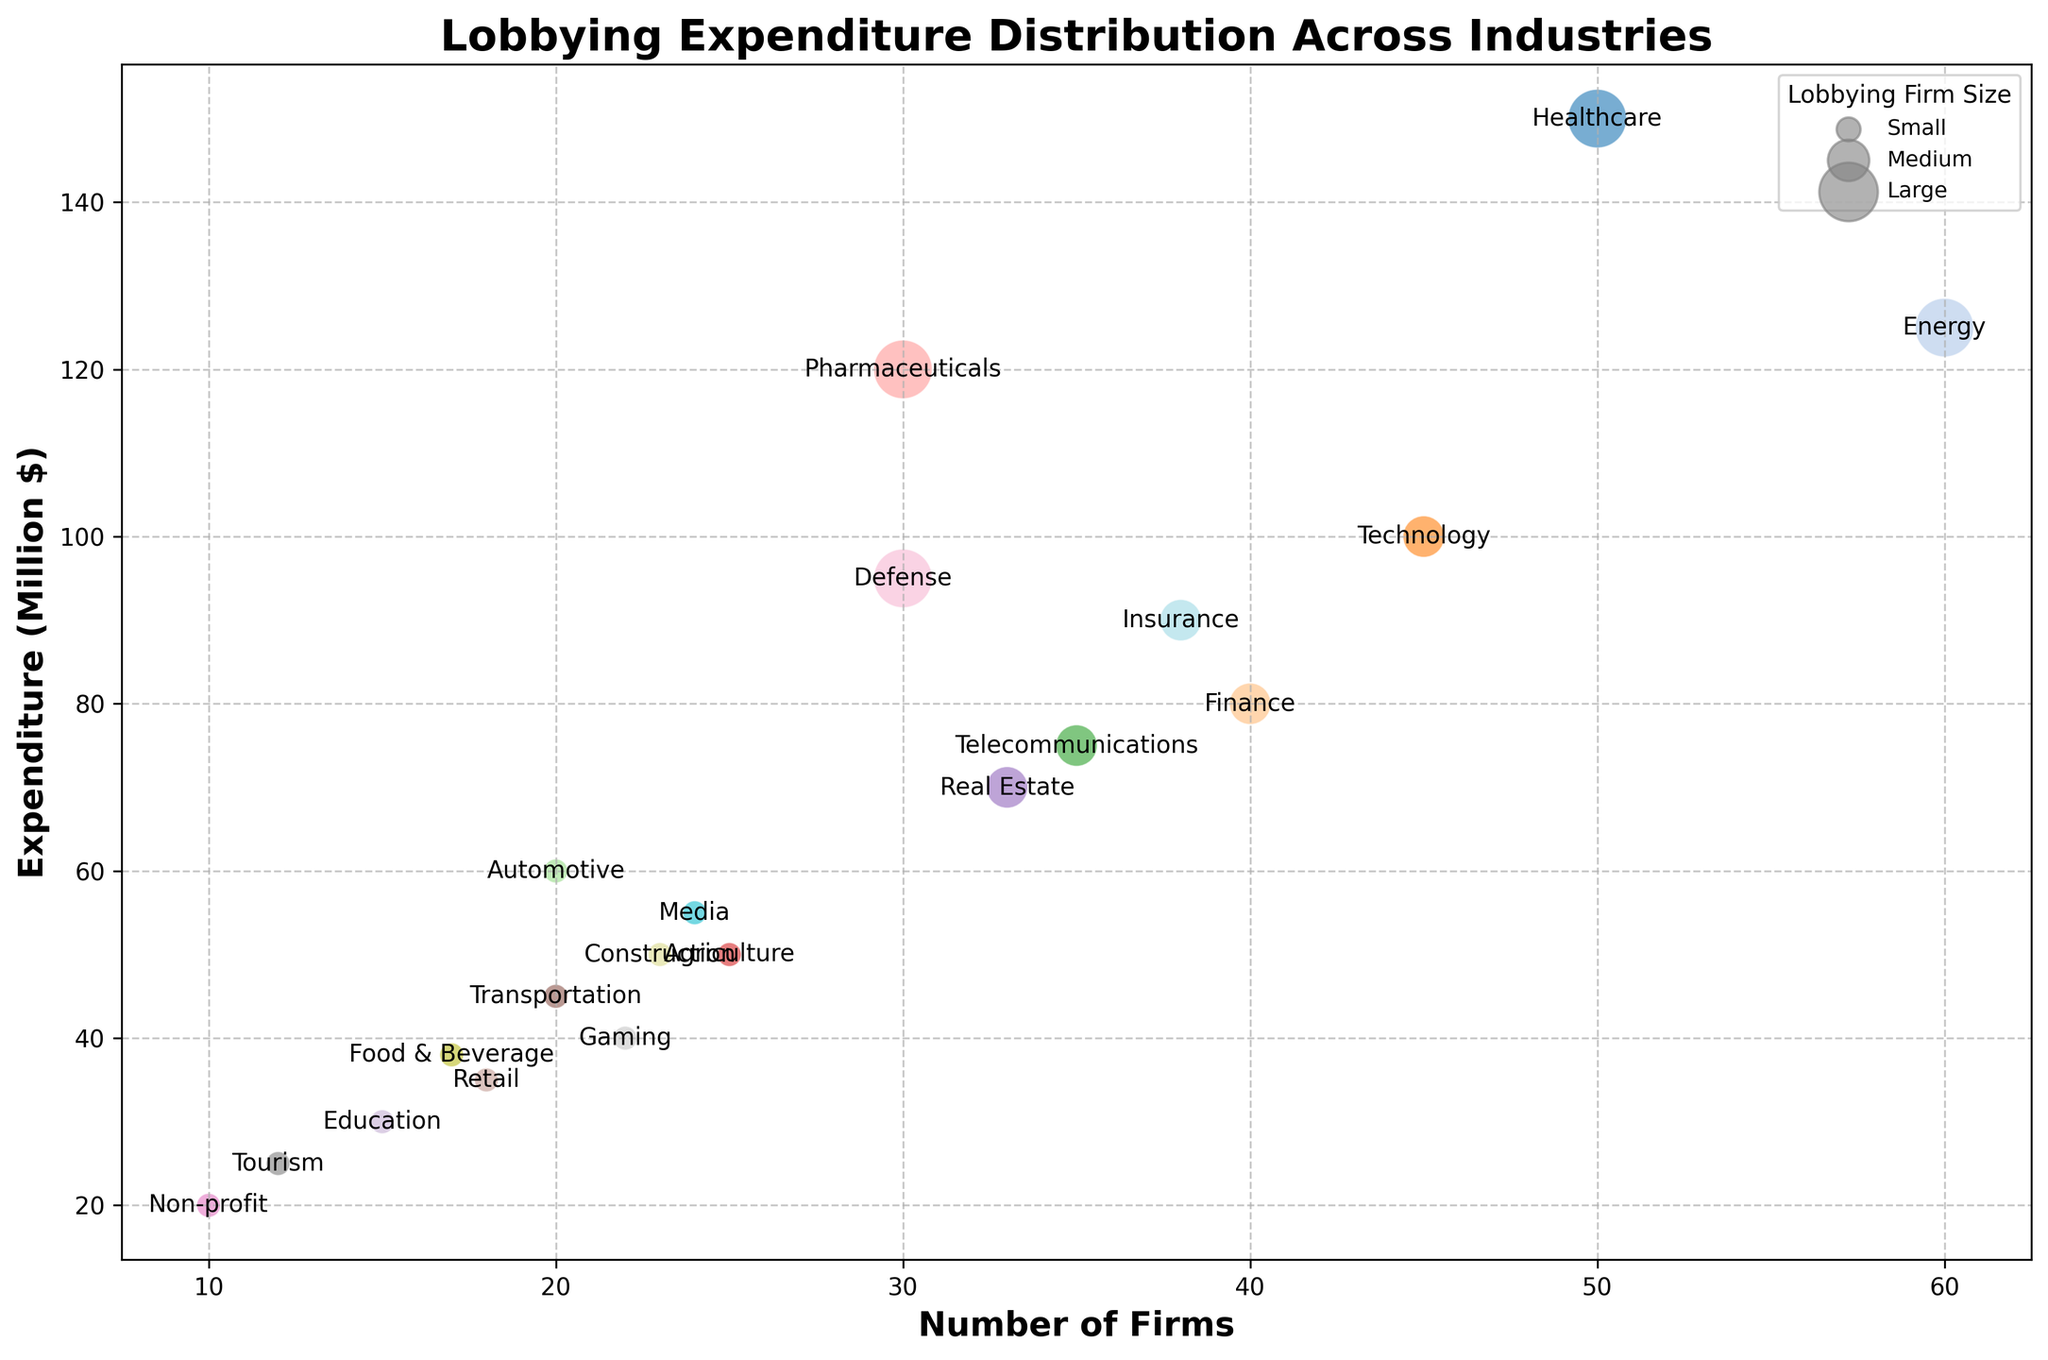What industry has the highest lobbying expenditure? Identify the bubble representing the highest y-axis value (Expenditure in Million $). The Healthcare industry's bubble is the highest.
Answer: Healthcare How many small lobbying firms are involved in the Automotive industry? Locate the Automotive industry's bubble and observe its coordinates. The hovering text or size indicates that it has 20 firms, of which all are small.
Answer: 20 Which industry has more lobbying firms: Energy or Technology? Compare the x-axis values (Number of Firms) for both industries. The Energy industry has 60 firms, whereas Technology has 45.
Answer: Energy What is the total expenditure of industries with medium-sized lobbying firms? Identify industries categorized as Medium in the legend and sum their expenditure values: Technology ($100M), Finance ($80M), Telecommunications ($75M), Real Estate ($70M), and Insurance ($90M). So, the total is $100M + $80M + $75M + $70M + $90M = $415M.
Answer: $415M How does the lobbying expenditure for Pharmaceuticals compare to that for Defense? Check the y-axis values of both bubbles. Pharmaceuticals ($120M) is higher than Defense ($95M).
Answer: Pharmaceuticals has higher expenditure Which industry in the plot has the lowest number of lobbying firms? Identify the bubble located lowest on the x-axis scale. The Non-profit industry's bubble is closest to 10 firms.
Answer: Non-profit What is the average number of firms for industries that have large lobbying firms? Locate and sum the x-axis values (Number of Firms) for Healthcare, Energy, Pharmaceuticals, and Defense. Then, divide by the count: (50 + 60 + 30 + 30) / 4 = 170 / 4 = 42.5.
Answer: 42.5 What color represents the Healthcare industry in the plot? Identify the unique color used for Healthcare's bubble by matching it visually with the legend or other bubbles.
Answer: [Provide the color from the chart.] Which industry has a higher lobbying expenditure: Telecommunications or Media? Check the y-axis values of both bubbles. Telecommunications ($75M) is higher than Media ($55M).
Answer: Telecommunications 